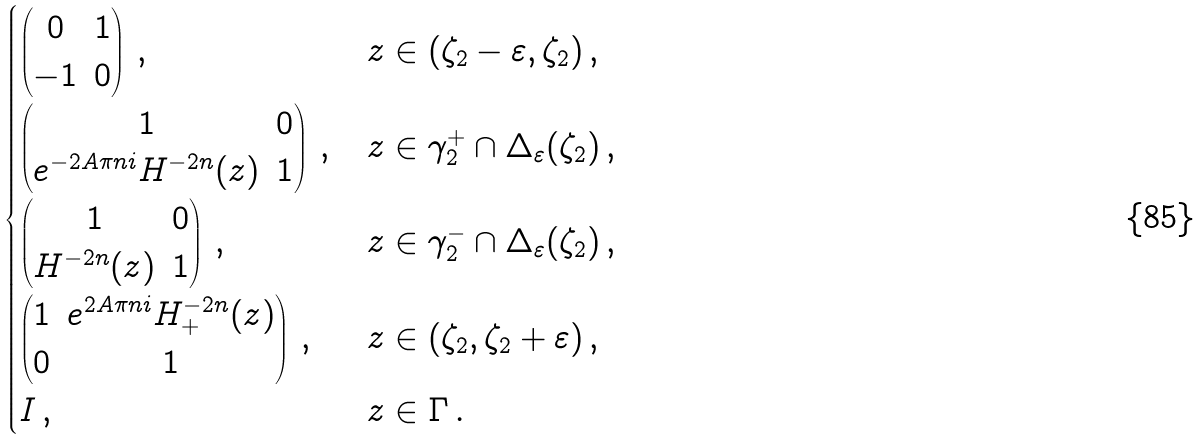<formula> <loc_0><loc_0><loc_500><loc_500>\begin{cases} \begin{pmatrix} 0 & 1 \\ - 1 & 0 \\ \end{pmatrix} \, , & z \in ( \zeta _ { 2 } - \varepsilon , \zeta _ { 2 } ) \, , \\ \begin{pmatrix} 1 & 0 \\ e ^ { - 2 A \pi n i } H ^ { - 2 n } ( z ) & 1 \\ \end{pmatrix} \, , & z \in \gamma _ { 2 } ^ { + } \cap \Delta _ { \varepsilon } ( \zeta _ { 2 } ) \, , \\ \begin{pmatrix} 1 & 0 \\ H ^ { - 2 n } ( z ) & 1 \\ \end{pmatrix} \, , & z \in \gamma _ { 2 } ^ { - } \cap \Delta _ { \varepsilon } ( \zeta _ { 2 } ) \, , \\ \begin{pmatrix} 1 & e ^ { 2 A \pi n i } H _ { + } ^ { - 2 n } ( z ) \\ 0 & 1 \\ \end{pmatrix} \, , & z \in ( \zeta _ { 2 } , \zeta _ { 2 } + \varepsilon ) \, , \\ I \, , & z \in \Gamma \, . \end{cases}</formula> 